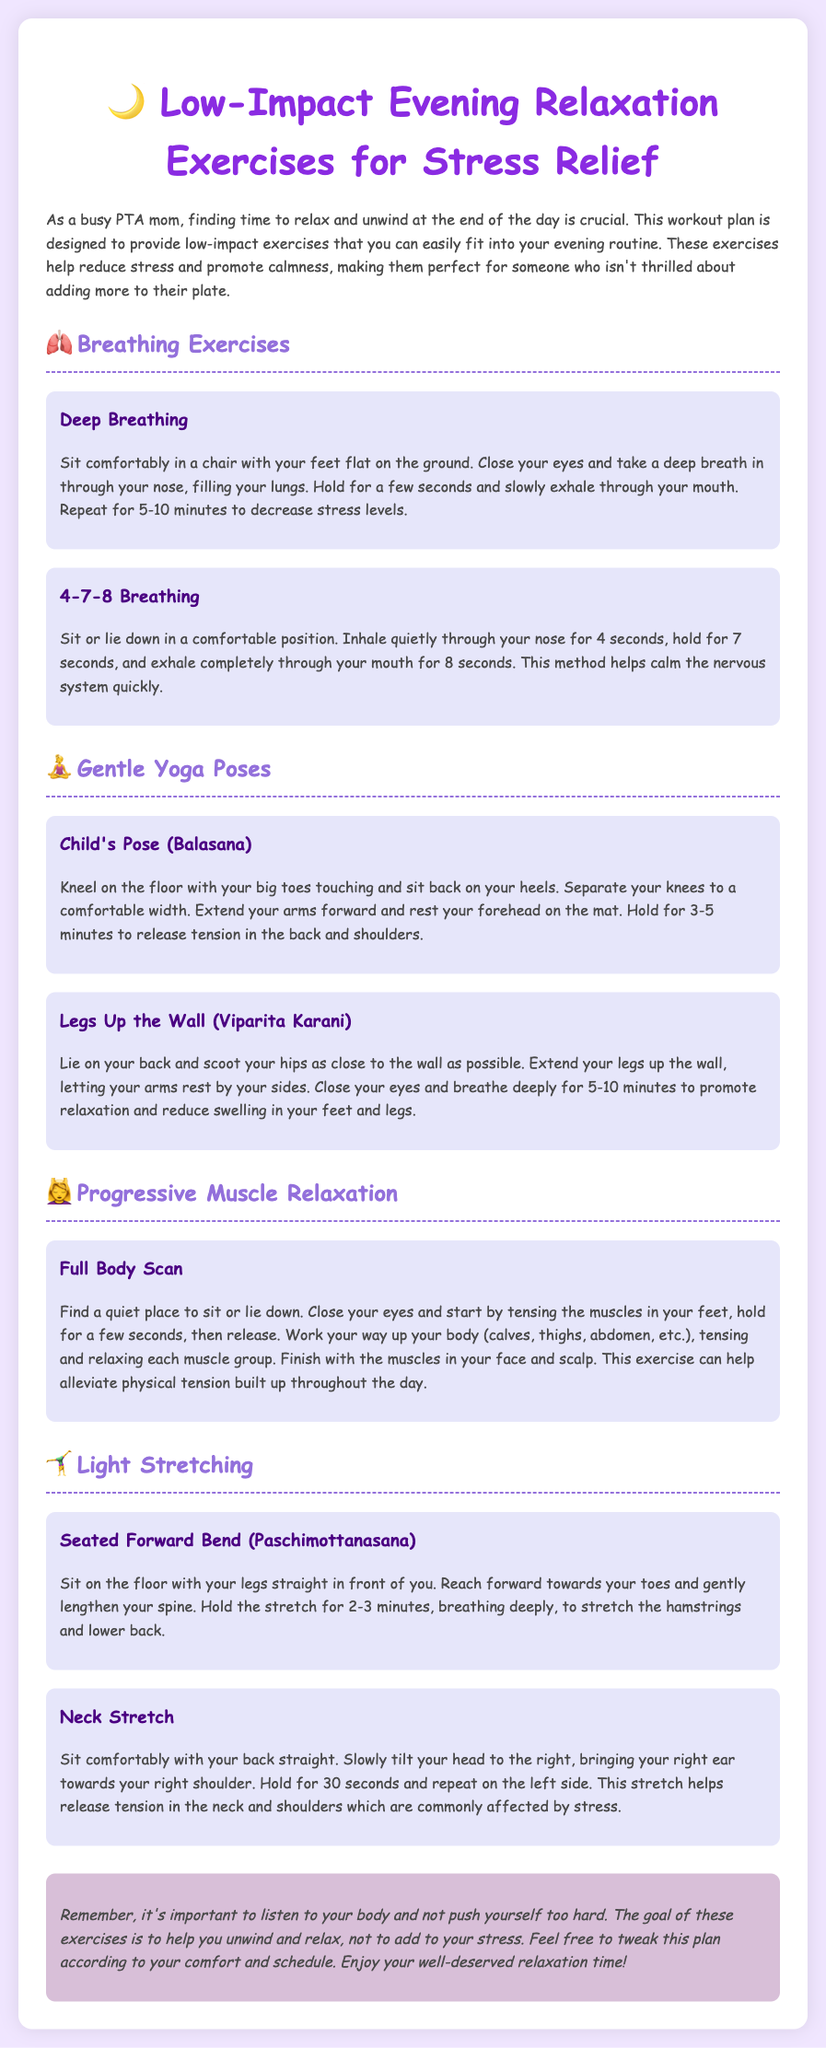What are the main sections in the workout plan? The main sections include Breathing Exercises, Gentle Yoga Poses, Progressive Muscle Relaxation, and Light Stretching.
Answer: Breathing Exercises, Gentle Yoga Poses, Progressive Muscle Relaxation, Light Stretching How long should you hold the Legs Up the Wall pose? The document states to close your eyes and breathe deeply for 5-10 minutes while in the pose.
Answer: 5-10 minutes What is the purpose of the Full Body Scan exercise? The Full Body Scan helps alleviate physical tension built up throughout the day.
Answer: Alleviate physical tension Which position is recommended for Deep Breathing? The recommended position for Deep Breathing is to sit comfortably in a chair with your feet flat on the ground.
Answer: Sit comfortably in a chair What does the Neck Stretch help with? The Neck Stretch helps release tension in the neck and shoulders, which are commonly affected by stress.
Answer: Release tension in the neck and shoulders What is the closing remark about listening to your body? It emphasizes the importance of not pushing yourself too hard and to help unwind and relax.
Answer: Don’t push yourself too hard How many seconds do you hold the Neck Stretch on each side? The document indicates to hold for 30 seconds on each side.
Answer: 30 seconds What is the style of the font used in the document? The style of the font used is Comic Sans MS.
Answer: Comic Sans MS 